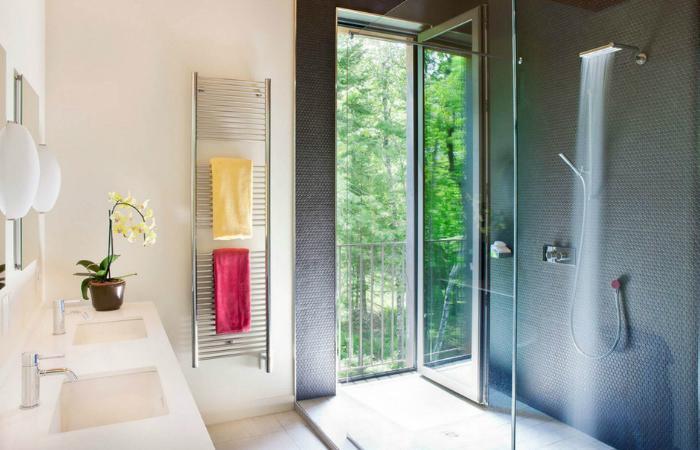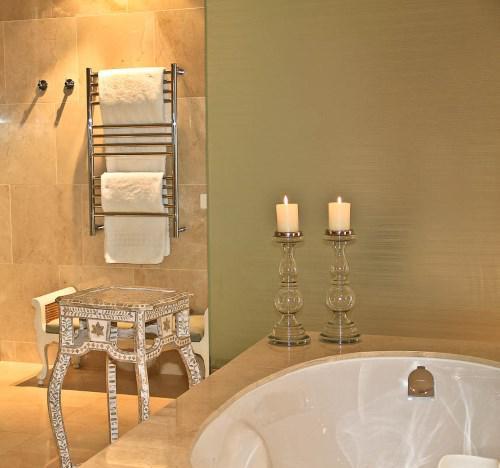The first image is the image on the left, the second image is the image on the right. Considering the images on both sides, is "In at least one image there is an open drawer holding towels." valid? Answer yes or no. No. The first image is the image on the left, the second image is the image on the right. Analyze the images presented: Is the assertion "The left image shows a pull-out drawer containing towels, with a long horizontal handle on the drawer." valid? Answer yes or no. No. 